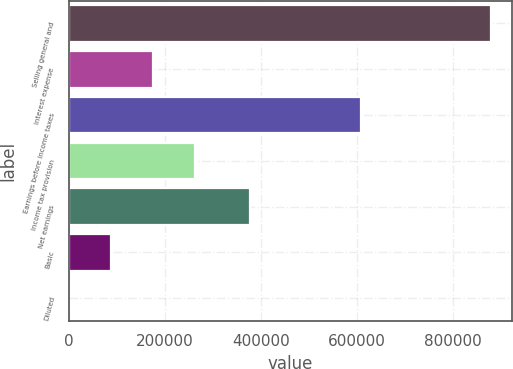<chart> <loc_0><loc_0><loc_500><loc_500><bar_chart><fcel>Selling general and<fcel>Interest expense<fcel>Earnings before income taxes<fcel>Income tax provision<fcel>Net earnings<fcel>Basic<fcel>Diluted<nl><fcel>878805<fcel>175762<fcel>608206<fcel>263643<fcel>377495<fcel>87882<fcel>1.65<nl></chart> 